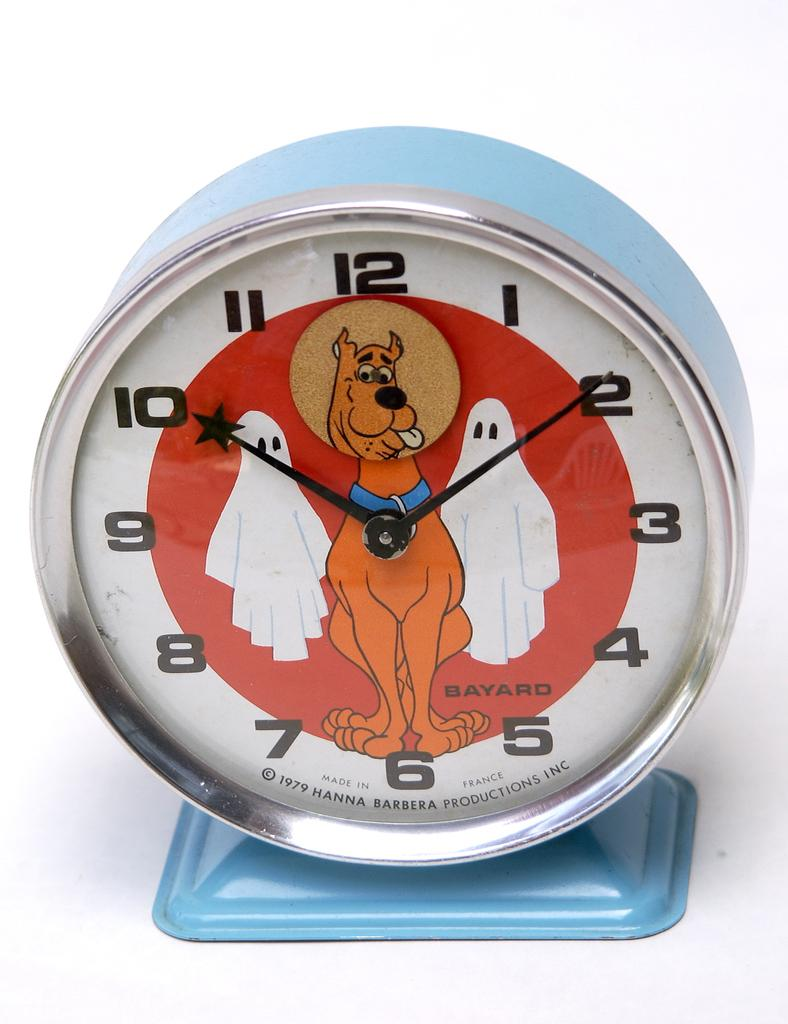Provide a one-sentence caption for the provided image. A 1979 clock from Hanna Barbera features Scooby Doo and some ghosts. 